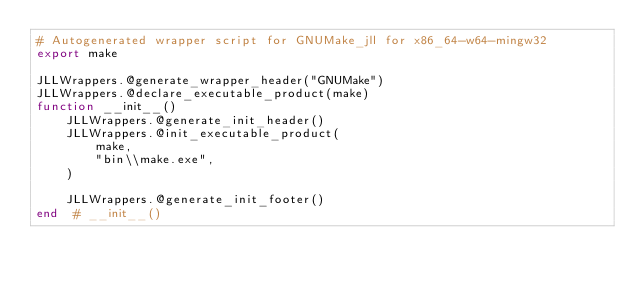<code> <loc_0><loc_0><loc_500><loc_500><_Julia_># Autogenerated wrapper script for GNUMake_jll for x86_64-w64-mingw32
export make

JLLWrappers.@generate_wrapper_header("GNUMake")
JLLWrappers.@declare_executable_product(make)
function __init__()
    JLLWrappers.@generate_init_header()
    JLLWrappers.@init_executable_product(
        make,
        "bin\\make.exe",
    )

    JLLWrappers.@generate_init_footer()
end  # __init__()
</code> 